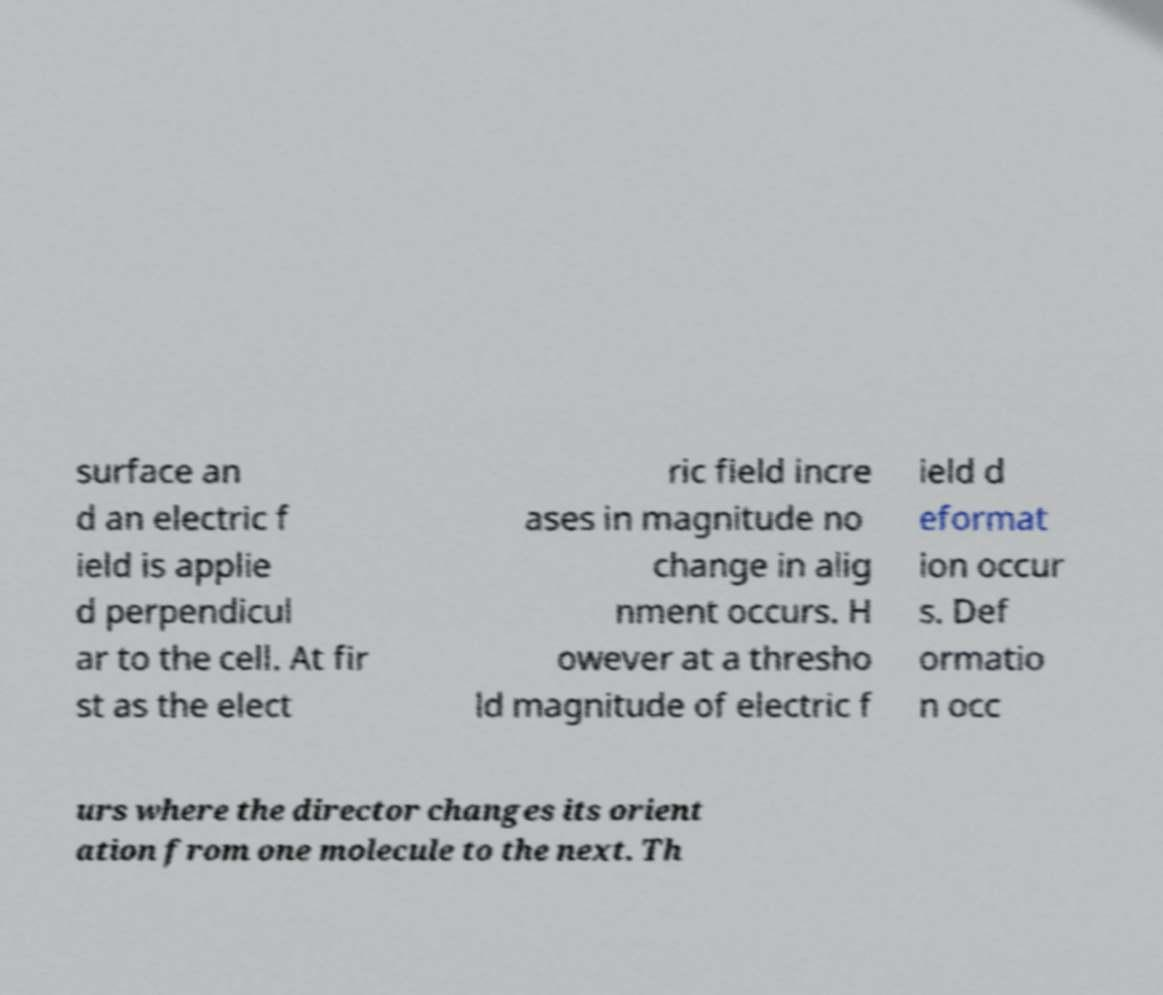Please identify and transcribe the text found in this image. surface an d an electric f ield is applie d perpendicul ar to the cell. At fir st as the elect ric field incre ases in magnitude no change in alig nment occurs. H owever at a thresho ld magnitude of electric f ield d eformat ion occur s. Def ormatio n occ urs where the director changes its orient ation from one molecule to the next. Th 